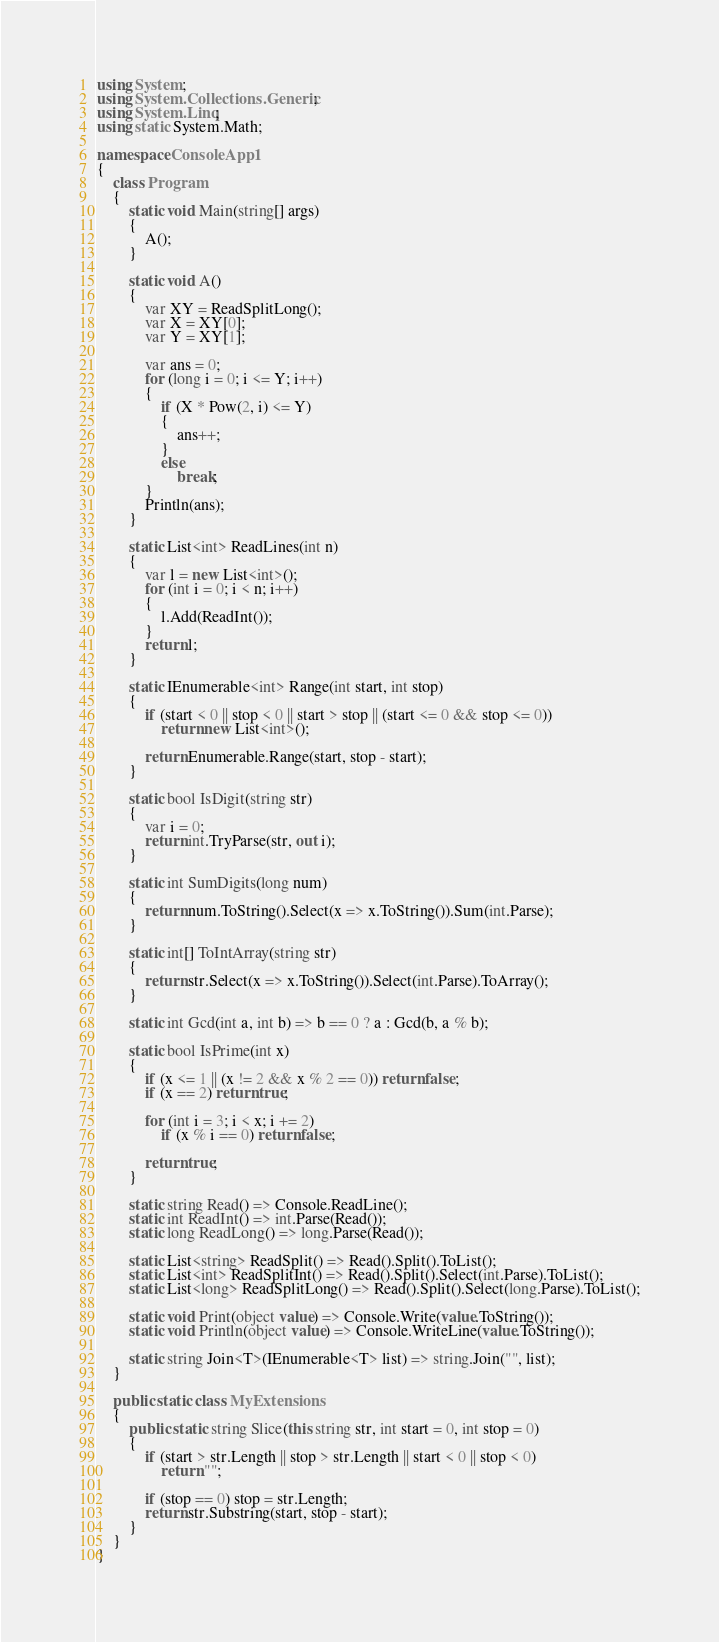<code> <loc_0><loc_0><loc_500><loc_500><_C#_>using System;
using System.Collections.Generic;
using System.Linq;
using static System.Math;

namespace ConsoleApp1
{
    class Program
    {
        static void Main(string[] args)
        {
            A();
        }

        static void A()
        {
            var XY = ReadSplitLong();
            var X = XY[0];
            var Y = XY[1];

            var ans = 0;
            for (long i = 0; i <= Y; i++)
            {
                if (X * Pow(2, i) <= Y)
                {
                    ans++;
                }
                else
                    break;
            }
            Println(ans);
        }

        static List<int> ReadLines(int n)
        {
            var l = new List<int>();
            for (int i = 0; i < n; i++)
            {
                l.Add(ReadInt());
            }
            return l;
        }

        static IEnumerable<int> Range(int start, int stop)
        {
            if (start < 0 || stop < 0 || start > stop || (start <= 0 && stop <= 0))
                return new List<int>();

            return Enumerable.Range(start, stop - start);
        }

        static bool IsDigit(string str)
        {
            var i = 0;
            return int.TryParse(str, out i);
        }

        static int SumDigits(long num)
        {
            return num.ToString().Select(x => x.ToString()).Sum(int.Parse);
        }

        static int[] ToIntArray(string str)
        {
            return str.Select(x => x.ToString()).Select(int.Parse).ToArray();
        }

        static int Gcd(int a, int b) => b == 0 ? a : Gcd(b, a % b);

        static bool IsPrime(int x)
        {
            if (x <= 1 || (x != 2 && x % 2 == 0)) return false;
            if (x == 2) return true;

            for (int i = 3; i < x; i += 2)
                if (x % i == 0) return false;

            return true;
        }

        static string Read() => Console.ReadLine();
        static int ReadInt() => int.Parse(Read());
        static long ReadLong() => long.Parse(Read());

        static List<string> ReadSplit() => Read().Split().ToList();
        static List<int> ReadSplitInt() => Read().Split().Select(int.Parse).ToList();
        static List<long> ReadSplitLong() => Read().Split().Select(long.Parse).ToList();

        static void Print(object value) => Console.Write(value.ToString());
        static void Println(object value) => Console.WriteLine(value.ToString());

        static string Join<T>(IEnumerable<T> list) => string.Join("", list);
    }

    public static class MyExtensions
    {
        public static string Slice(this string str, int start = 0, int stop = 0)
        {
            if (start > str.Length || stop > str.Length || start < 0 || stop < 0)
                return "";

            if (stop == 0) stop = str.Length;
            return str.Substring(start, stop - start);
        }
    }
}</code> 